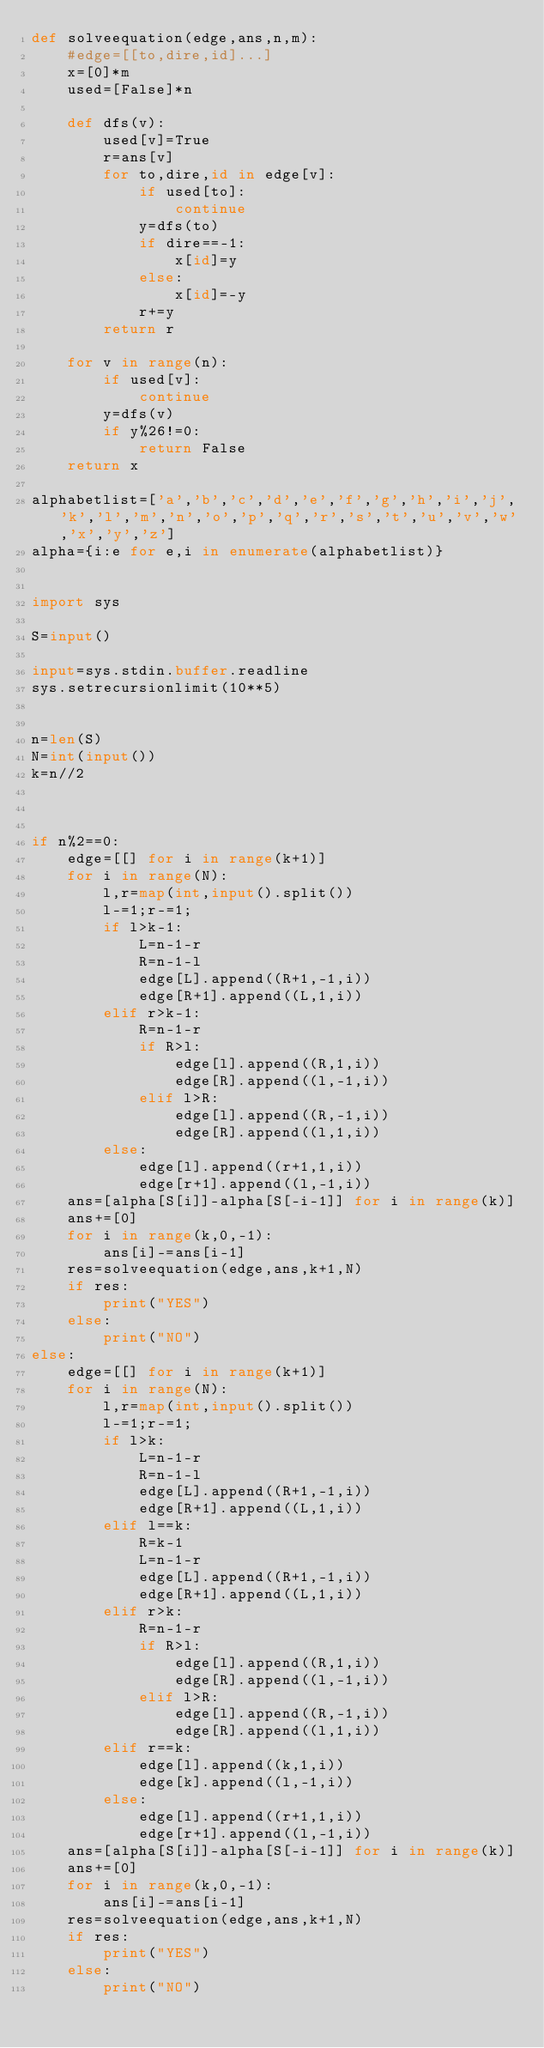<code> <loc_0><loc_0><loc_500><loc_500><_Python_>def solveequation(edge,ans,n,m):
    #edge=[[to,dire,id]...]
    x=[0]*m
    used=[False]*n

    def dfs(v):
        used[v]=True
        r=ans[v]
        for to,dire,id in edge[v]:
            if used[to]:
                continue
            y=dfs(to)
            if dire==-1:
                x[id]=y
            else:
                x[id]=-y
            r+=y
        return r

    for v in range(n):
        if used[v]:
            continue
        y=dfs(v)
        if y%26!=0:
            return False
    return x

alphabetlist=['a','b','c','d','e','f','g','h','i','j','k','l','m','n','o','p','q','r','s','t','u','v','w','x','y','z']
alpha={i:e for e,i in enumerate(alphabetlist)}


import sys

S=input()

input=sys.stdin.buffer.readline
sys.setrecursionlimit(10**5)


n=len(S)
N=int(input())
k=n//2



if n%2==0:
    edge=[[] for i in range(k+1)]
    for i in range(N):
        l,r=map(int,input().split())
        l-=1;r-=1;
        if l>k-1:
            L=n-1-r
            R=n-1-l
            edge[L].append((R+1,-1,i))
            edge[R+1].append((L,1,i))
        elif r>k-1:
            R=n-1-r
            if R>l:
                edge[l].append((R,1,i))
                edge[R].append((l,-1,i))
            elif l>R:
                edge[l].append((R,-1,i))
                edge[R].append((l,1,i))
        else:
            edge[l].append((r+1,1,i))
            edge[r+1].append((l,-1,i))
    ans=[alpha[S[i]]-alpha[S[-i-1]] for i in range(k)]
    ans+=[0]
    for i in range(k,0,-1):
        ans[i]-=ans[i-1]
    res=solveequation(edge,ans,k+1,N)
    if res:
        print("YES")
    else:
        print("NO")
else:
    edge=[[] for i in range(k+1)]
    for i in range(N):
        l,r=map(int,input().split())
        l-=1;r-=1;
        if l>k:
            L=n-1-r
            R=n-1-l
            edge[L].append((R+1,-1,i))
            edge[R+1].append((L,1,i))
        elif l==k:
            R=k-1
            L=n-1-r
            edge[L].append((R+1,-1,i))
            edge[R+1].append((L,1,i))
        elif r>k:
            R=n-1-r
            if R>l:
                edge[l].append((R,1,i))
                edge[R].append((l,-1,i))
            elif l>R:
                edge[l].append((R,-1,i))
                edge[R].append((l,1,i))
        elif r==k:
            edge[l].append((k,1,i))
            edge[k].append((l,-1,i))
        else:
            edge[l].append((r+1,1,i))
            edge[r+1].append((l,-1,i))
    ans=[alpha[S[i]]-alpha[S[-i-1]] for i in range(k)]
    ans+=[0]
    for i in range(k,0,-1):
        ans[i]-=ans[i-1]
    res=solveequation(edge,ans,k+1,N)
    if res:
        print("YES")
    else:
        print("NO")</code> 